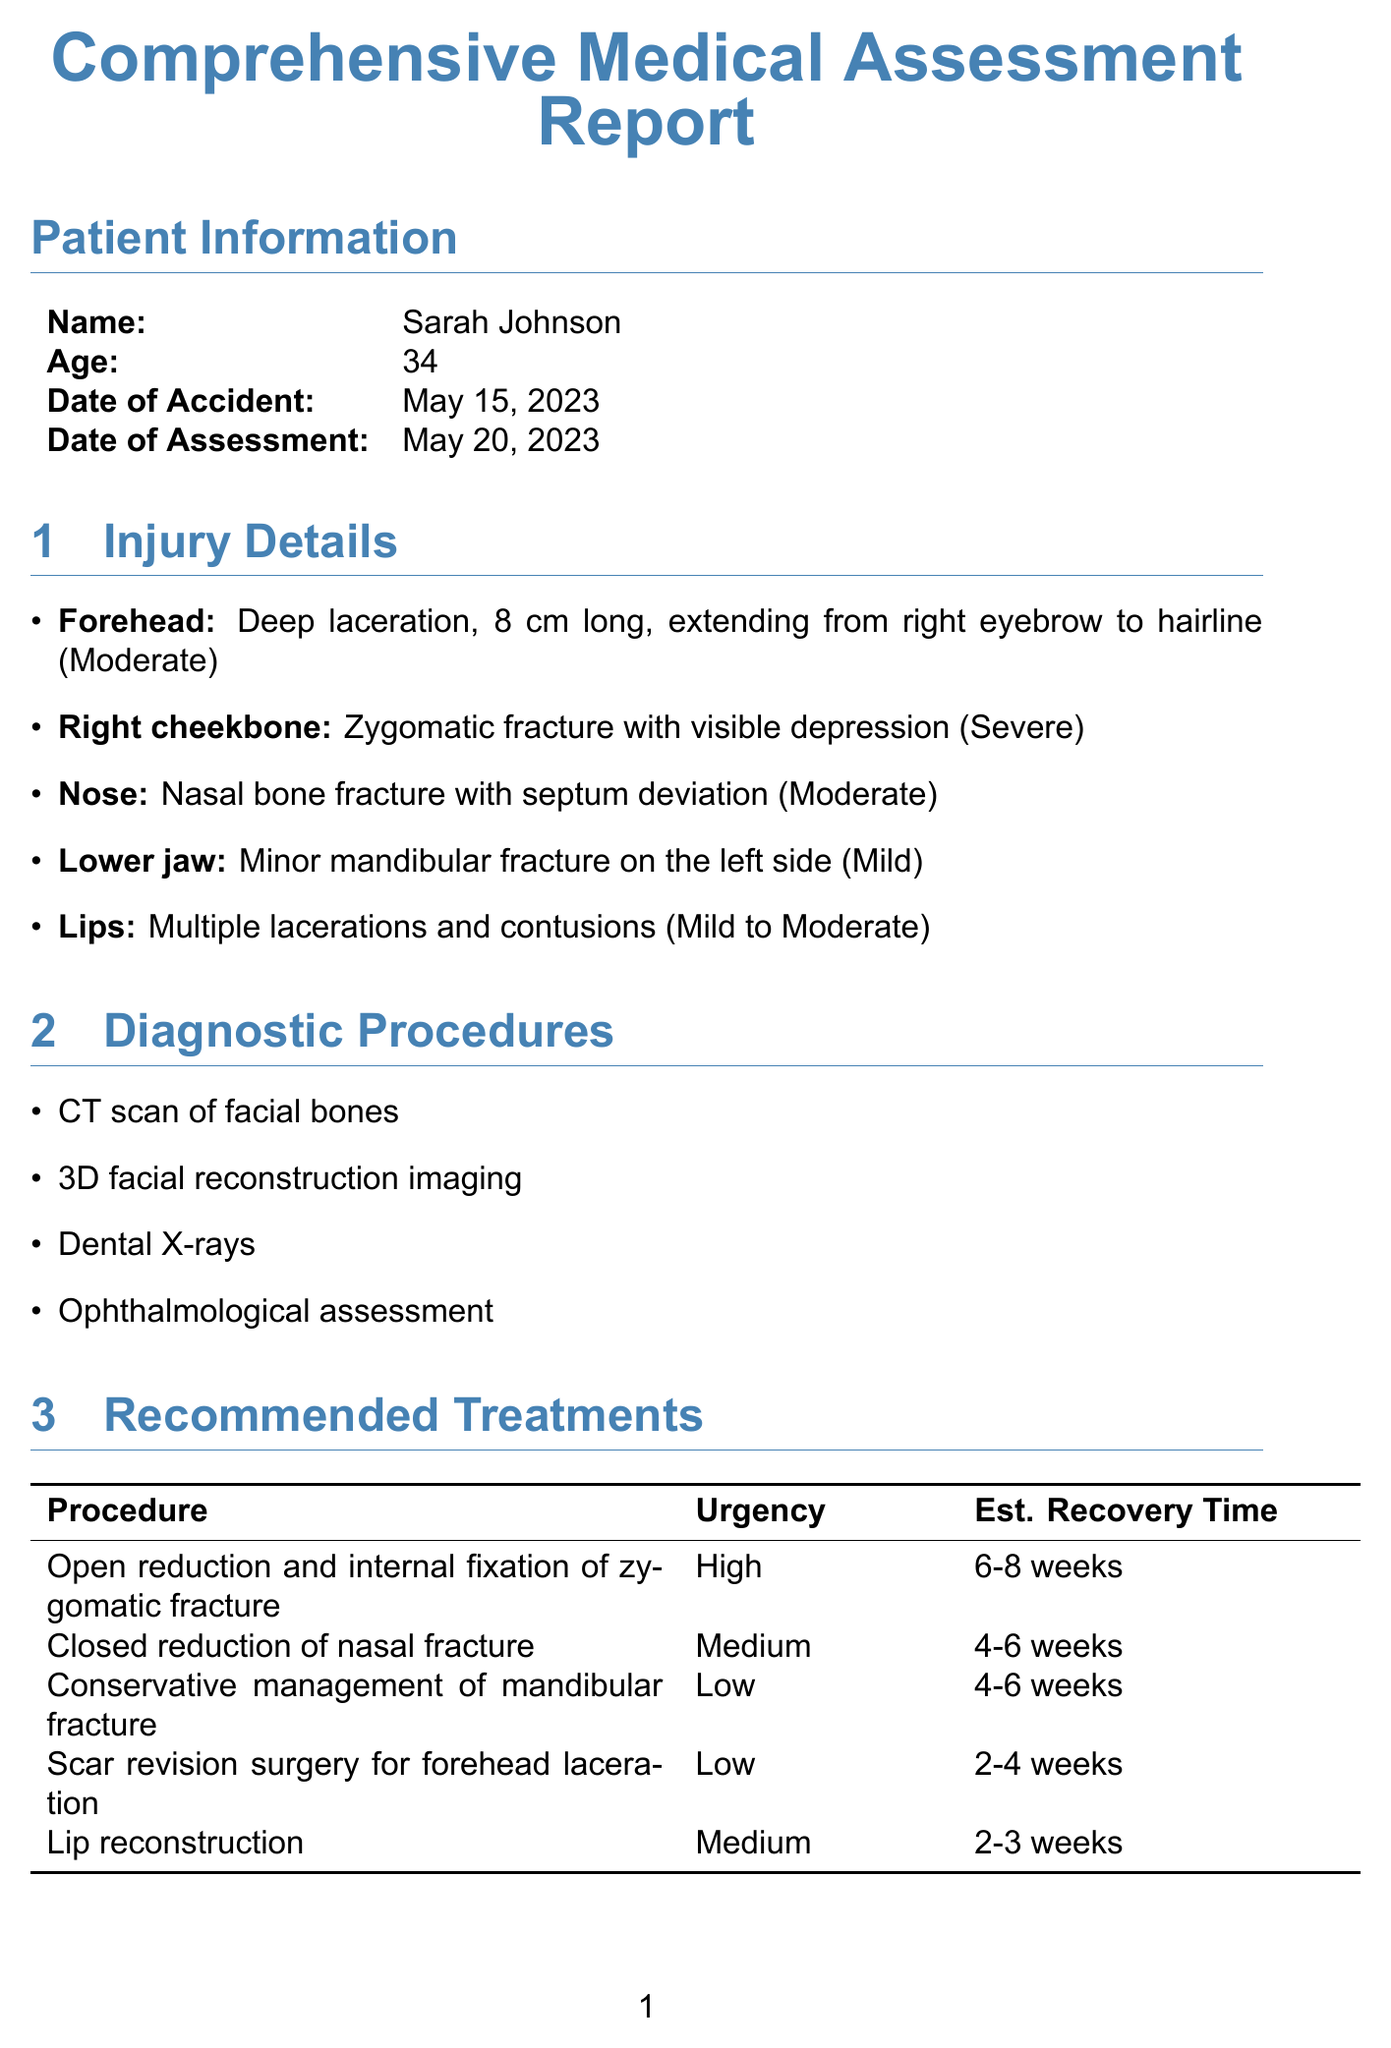What is the name of the patient? The patient's name is stated in the patient information section of the report.
Answer: Sarah Johnson What procedure is recommended for the zygomatic fracture? The procedure for the zygomatic fracture is listed in the recommended treatments section.
Answer: Open reduction and internal fixation of zygomatic fracture What is the age of the patient? The patient's age is provided in the patient information section of the report.
Answer: 34 How long is the estimated recovery time for lip reconstruction? The estimated recovery time for lip reconstruction can be found in the recommended treatments section.
Answer: 2-3 weeks What are the potential aesthetic outcomes listed? The potential aesthetic outcomes are specified in the potential outcomes section of the report.
Answer: Minimal visible scarring on forehead, restored cheekbone contour, improved nasal appearance, enhanced overall facial harmony What is the duration of the psychological support recommended? The duration of the psychological support is detailed in the psychological support section of the report.
Answer: 12-16 sessions How many times per week is facial massage recommended in the rehabilitation plan? The frequency of facial massage is listed in the rehabilitation plan section of the report.
Answer: 2 times per week Who is the treating physician for maxillofacial surgery? The name of the treating physician is found in the treating physicians section of the report.
Answer: Dr. Emily Chen What is the severity of the injury on the right cheekbone? The severity of the injury is stated in the injury details section of the report.
Answer: Severe 